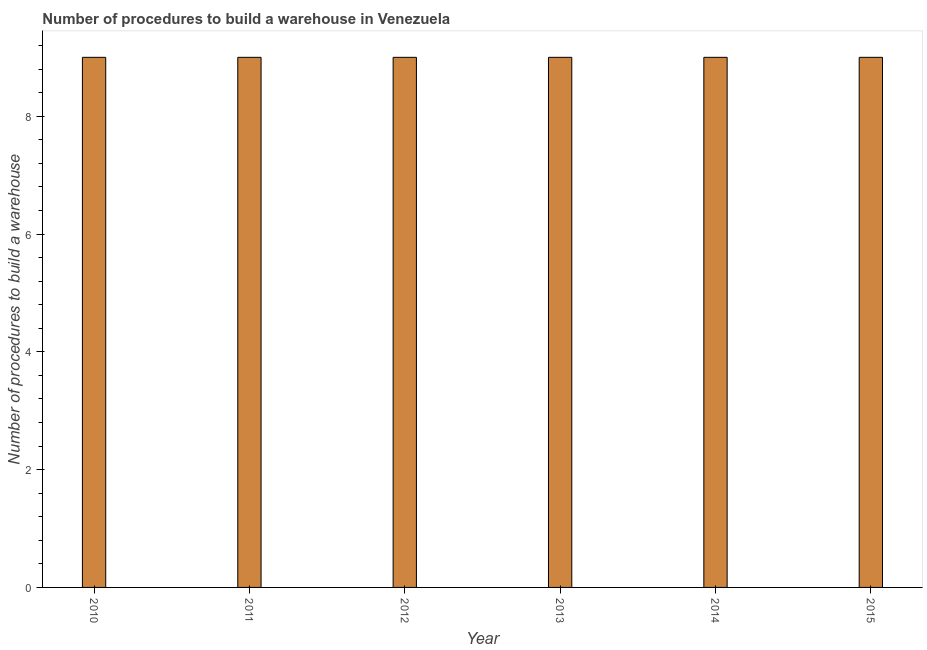Does the graph contain grids?
Offer a very short reply. No. What is the title of the graph?
Your response must be concise. Number of procedures to build a warehouse in Venezuela. What is the label or title of the Y-axis?
Your response must be concise. Number of procedures to build a warehouse. Across all years, what is the maximum number of procedures to build a warehouse?
Offer a terse response. 9. In which year was the number of procedures to build a warehouse minimum?
Your response must be concise. 2010. What is the difference between the number of procedures to build a warehouse in 2010 and 2013?
Provide a short and direct response. 0. What is the average number of procedures to build a warehouse per year?
Provide a short and direct response. 9. What is the median number of procedures to build a warehouse?
Provide a succinct answer. 9. In how many years, is the number of procedures to build a warehouse greater than 0.4 ?
Ensure brevity in your answer.  6. Do a majority of the years between 2015 and 2013 (inclusive) have number of procedures to build a warehouse greater than 2.4 ?
Your response must be concise. Yes. What is the ratio of the number of procedures to build a warehouse in 2011 to that in 2012?
Your answer should be very brief. 1. Is the number of procedures to build a warehouse in 2011 less than that in 2012?
Make the answer very short. No. Are all the bars in the graph horizontal?
Keep it short and to the point. No. What is the difference between two consecutive major ticks on the Y-axis?
Provide a short and direct response. 2. Are the values on the major ticks of Y-axis written in scientific E-notation?
Offer a very short reply. No. What is the Number of procedures to build a warehouse in 2010?
Your answer should be compact. 9. What is the difference between the Number of procedures to build a warehouse in 2010 and 2012?
Provide a short and direct response. 0. What is the difference between the Number of procedures to build a warehouse in 2011 and 2012?
Keep it short and to the point. 0. What is the difference between the Number of procedures to build a warehouse in 2012 and 2013?
Provide a succinct answer. 0. What is the difference between the Number of procedures to build a warehouse in 2012 and 2014?
Make the answer very short. 0. What is the difference between the Number of procedures to build a warehouse in 2012 and 2015?
Ensure brevity in your answer.  0. What is the difference between the Number of procedures to build a warehouse in 2013 and 2014?
Provide a succinct answer. 0. What is the difference between the Number of procedures to build a warehouse in 2014 and 2015?
Provide a succinct answer. 0. What is the ratio of the Number of procedures to build a warehouse in 2010 to that in 2012?
Make the answer very short. 1. What is the ratio of the Number of procedures to build a warehouse in 2010 to that in 2015?
Offer a very short reply. 1. What is the ratio of the Number of procedures to build a warehouse in 2011 to that in 2012?
Provide a short and direct response. 1. What is the ratio of the Number of procedures to build a warehouse in 2011 to that in 2013?
Your answer should be compact. 1. What is the ratio of the Number of procedures to build a warehouse in 2011 to that in 2014?
Make the answer very short. 1. What is the ratio of the Number of procedures to build a warehouse in 2012 to that in 2013?
Make the answer very short. 1. What is the ratio of the Number of procedures to build a warehouse in 2012 to that in 2014?
Your response must be concise. 1. What is the ratio of the Number of procedures to build a warehouse in 2012 to that in 2015?
Your answer should be compact. 1. What is the ratio of the Number of procedures to build a warehouse in 2013 to that in 2014?
Provide a succinct answer. 1. 